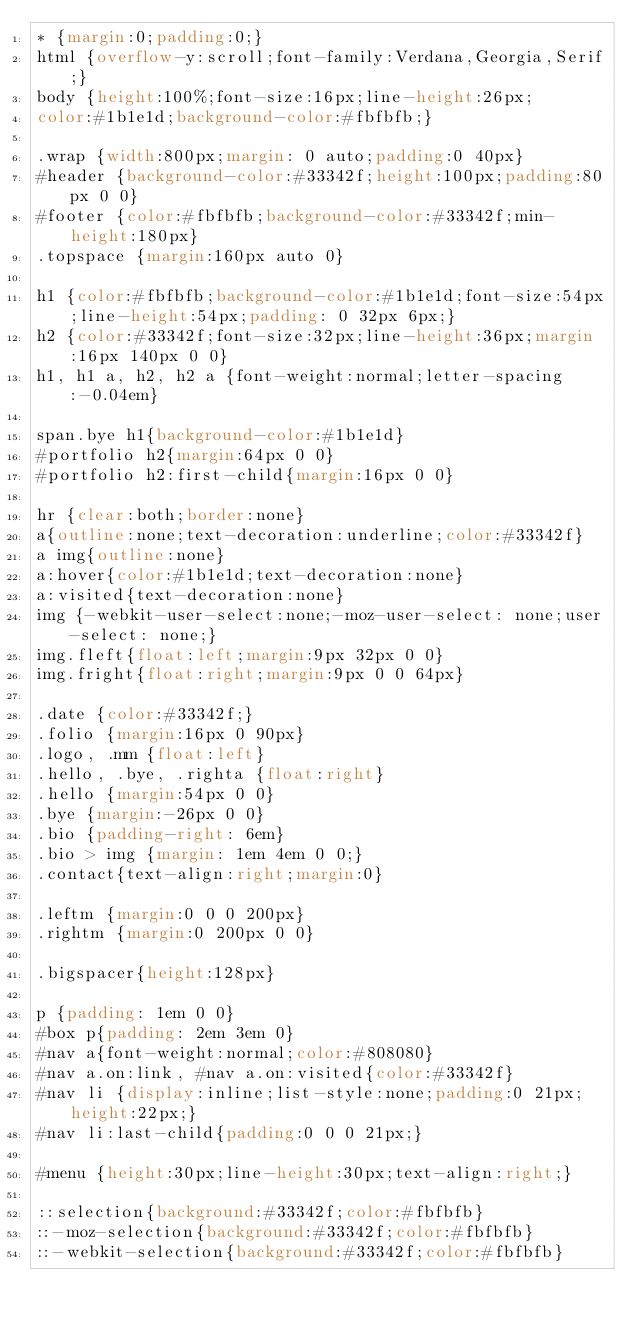<code> <loc_0><loc_0><loc_500><loc_500><_CSS_>* {margin:0;padding:0;}
html {overflow-y:scroll;font-family:Verdana,Georgia,Serif;}
body {height:100%;font-size:16px;line-height:26px;
color:#1b1e1d;background-color:#fbfbfb;}

.wrap {width:800px;margin: 0 auto;padding:0 40px}
#header {background-color:#33342f;height:100px;padding:80px 0 0}
#footer {color:#fbfbfb;background-color:#33342f;min-height:180px}
.topspace {margin:160px auto 0}

h1 {color:#fbfbfb;background-color:#1b1e1d;font-size:54px;line-height:54px;padding: 0 32px 6px;}
h2 {color:#33342f;font-size:32px;line-height:36px;margin:16px 140px 0 0}
h1, h1 a, h2, h2 a {font-weight:normal;letter-spacing:-0.04em}

span.bye h1{background-color:#1b1e1d}
#portfolio h2{margin:64px 0 0}
#portfolio h2:first-child{margin:16px 0 0}

hr {clear:both;border:none}
a{outline:none;text-decoration:underline;color:#33342f}
a img{outline:none}
a:hover{color:#1b1e1d;text-decoration:none}
a:visited{text-decoration:none}
img {-webkit-user-select:none;-moz-user-select: none;user-select: none;}
img.fleft{float:left;margin:9px 32px 0 0}
img.fright{float:right;margin:9px 0 0 64px}

.date {color:#33342f;}
.folio {margin:16px 0 90px}
.logo, .mm {float:left}
.hello, .bye, .righta {float:right}
.hello {margin:54px 0 0}
.bye {margin:-26px 0 0}
.bio {padding-right: 6em}
.bio > img {margin: 1em 4em 0 0;} 
.contact{text-align:right;margin:0}

.leftm {margin:0 0 0 200px}
.rightm {margin:0 200px 0 0}

.bigspacer{height:128px}

p {padding: 1em 0 0}
#box p{padding: 2em 3em 0}
#nav a{font-weight:normal;color:#808080}
#nav a.on:link, #nav a.on:visited{color:#33342f}
#nav li {display:inline;list-style:none;padding:0 21px;height:22px;}
#nav li:last-child{padding:0 0 0 21px;}

#menu {height:30px;line-height:30px;text-align:right;}

::selection{background:#33342f;color:#fbfbfb}
::-moz-selection{background:#33342f;color:#fbfbfb}
::-webkit-selection{background:#33342f;color:#fbfbfb}

</code> 